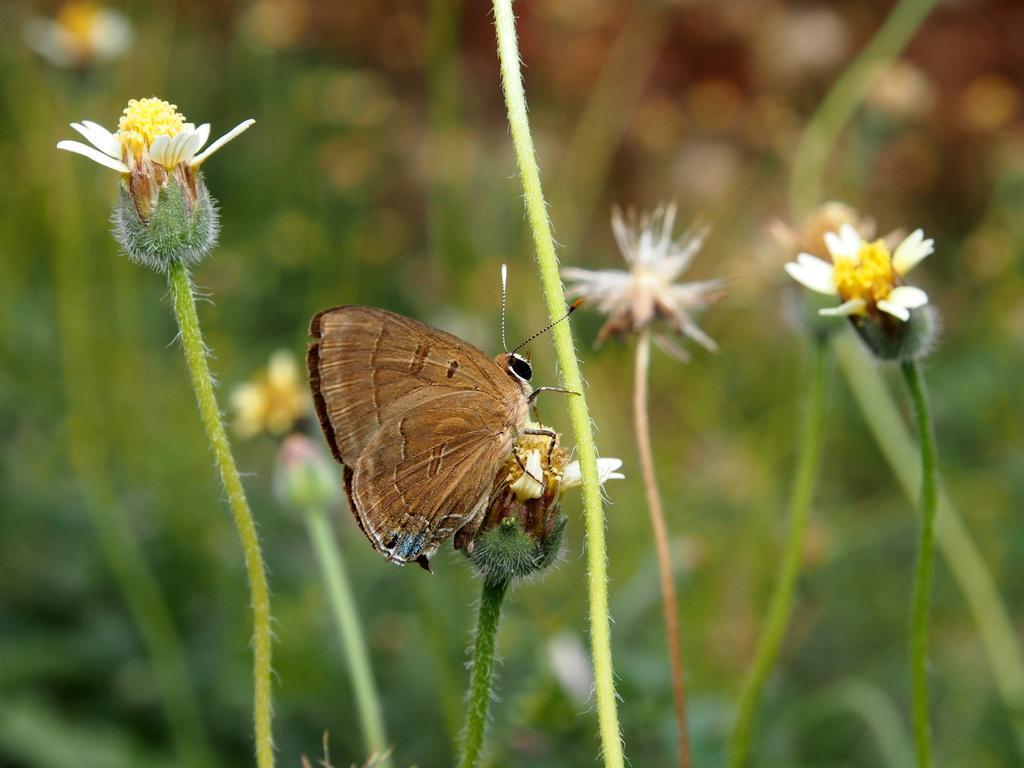In one or two sentences, can you explain what this image depicts? In this image I can see a butterfly is on the flower. It is in brown and black color. I can see few flowers which is in white and yellow color. Background is blurred. 